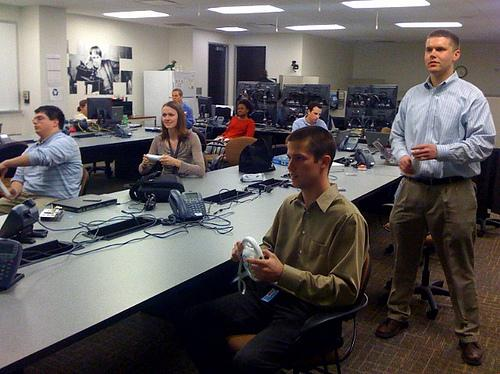What is the man in the brown shirt emulating with the white controller? Please explain your reasoning. driving. The man is holding a car steering wheel which is an accessory that is used in a popular video racing game. 